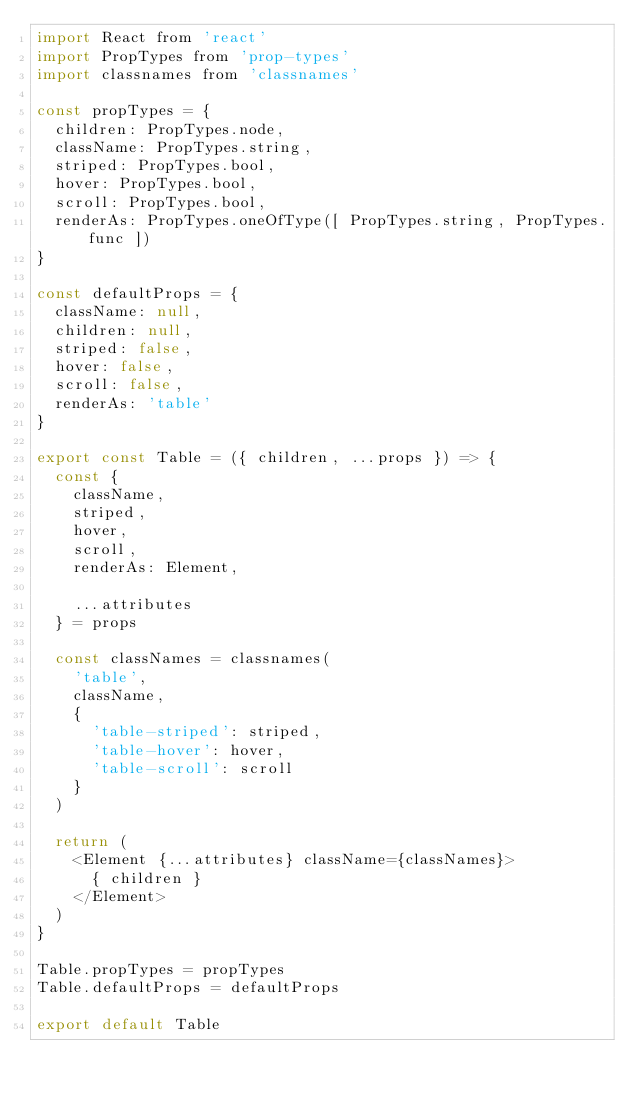<code> <loc_0><loc_0><loc_500><loc_500><_JavaScript_>import React from 'react'
import PropTypes from 'prop-types'
import classnames from 'classnames'

const propTypes = {
  children: PropTypes.node,
  className: PropTypes.string,
  striped: PropTypes.bool,
  hover: PropTypes.bool,
  scroll: PropTypes.bool,
  renderAs: PropTypes.oneOfType([ PropTypes.string, PropTypes.func ])
}

const defaultProps = {
  className: null,
  children: null,
  striped: false,
  hover: false,
  scroll: false,
  renderAs: 'table'
}

export const Table = ({ children, ...props }) => {
  const {
    className,
    striped,
    hover,
    scroll,
    renderAs: Element,

    ...attributes
  } = props

  const classNames = classnames(
    'table',
    className,
    {
      'table-striped': striped,
      'table-hover': hover,
      'table-scroll': scroll
    }
  )

  return (
    <Element {...attributes} className={classNames}>
      { children }
    </Element>
  )
}

Table.propTypes = propTypes
Table.defaultProps = defaultProps

export default Table
</code> 